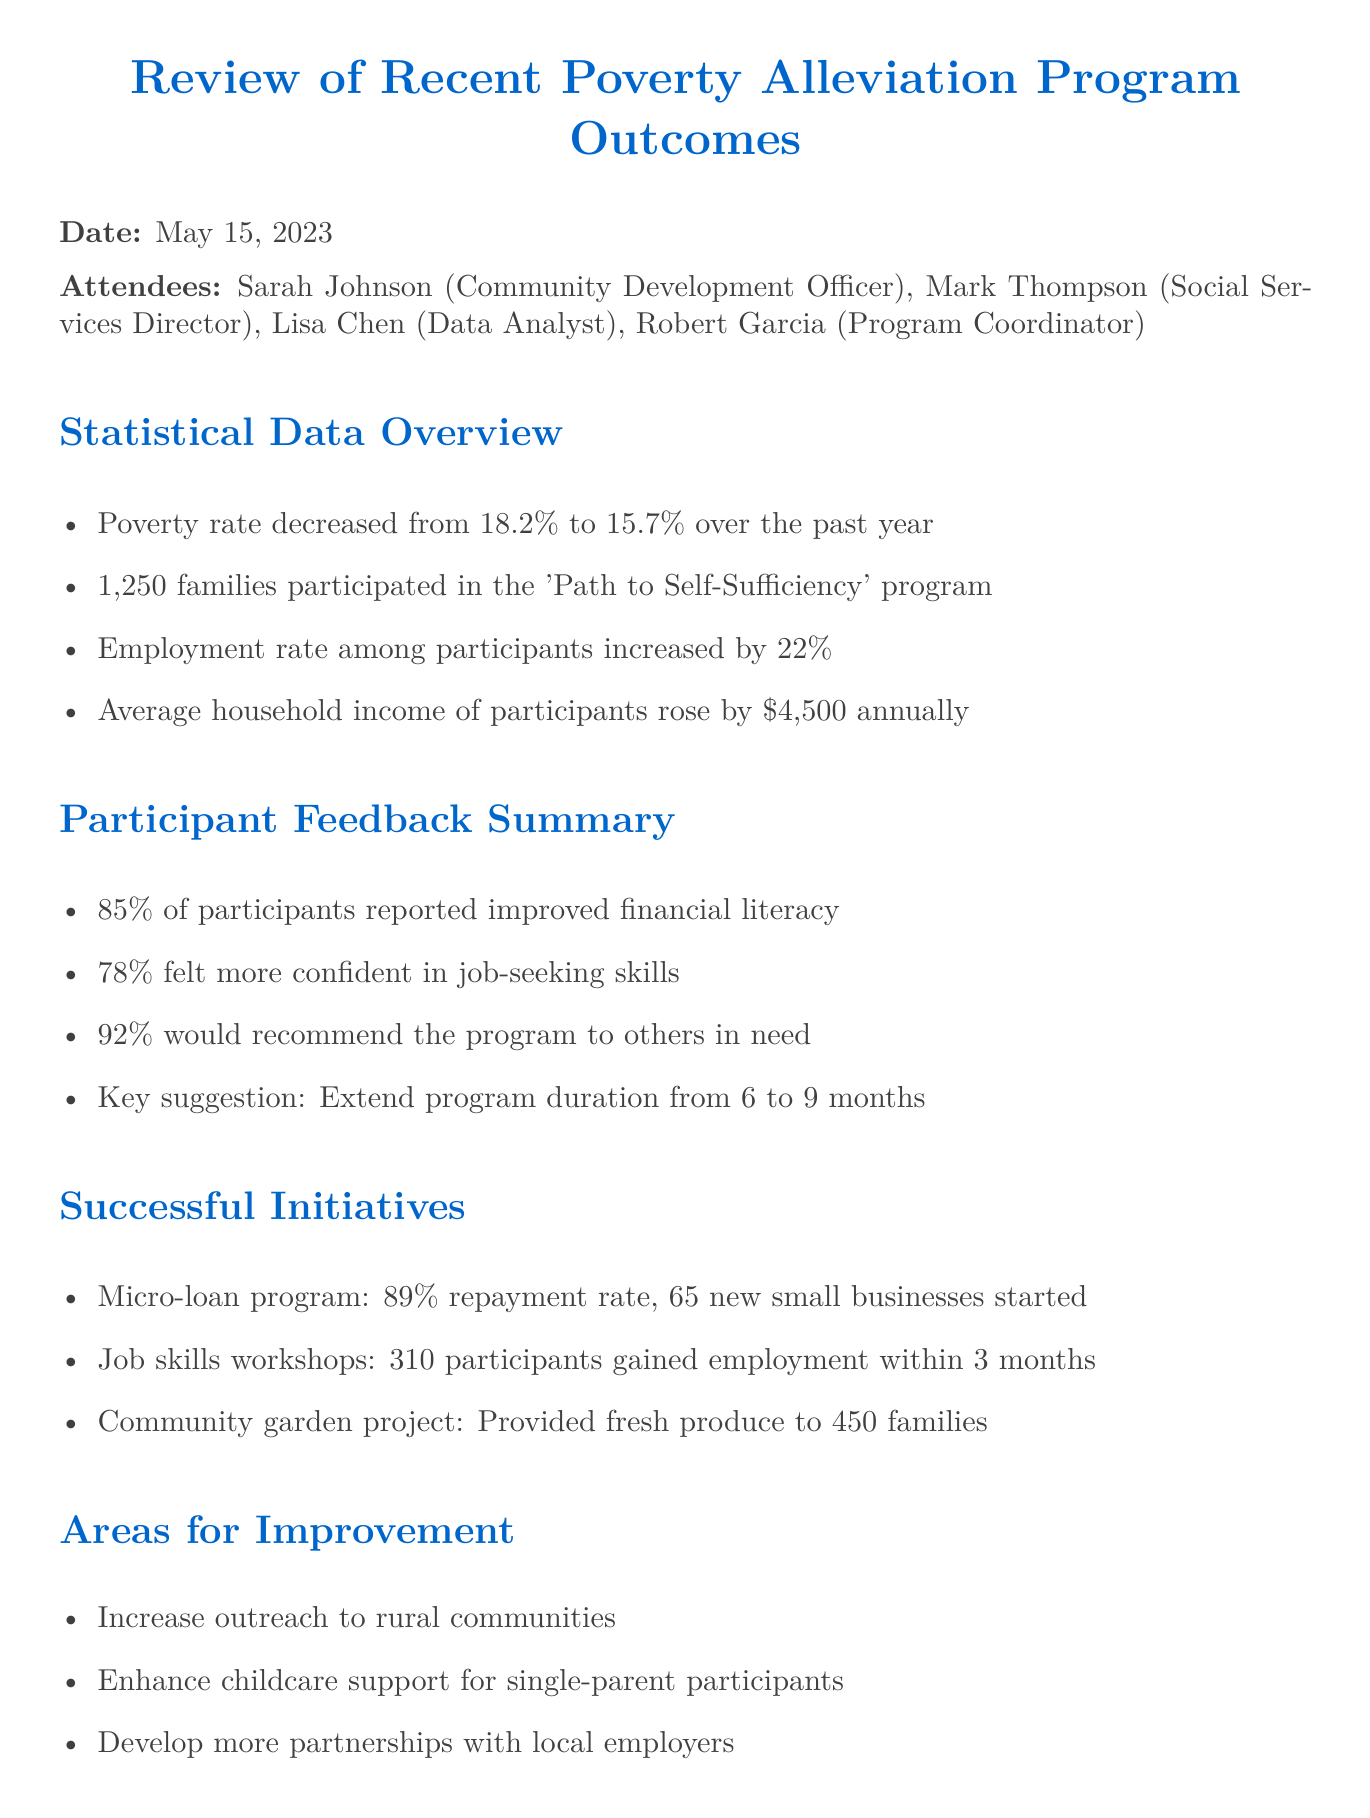What was the poverty rate decrease over the past year? The document states that the poverty rate decreased from 18.2% to 15.7%. The difference is 2.5%.
Answer: 2.5% How many families participated in the 'Path to Self-Sufficiency' program? The document explicitly mentions that 1,250 families participated in the program.
Answer: 1,250 What percentage of participants reported improved financial literacy? The meeting minutes indicate that 85% of participants reported improved financial literacy.
Answer: 85% What key suggestion was made by participants regarding the program duration? The document notes that participants suggested extending the program duration from 6 to 9 months.
Answer: Extend program duration from 6 to 9 months How many new small businesses were started through the micro-loan program? According to the document, the micro-loan program led to the establishment of 65 new small businesses.
Answer: 65 What is the average increase in household income among participants? The document reveals that the average household income of participants rose by $4,500 annually.
Answer: $4,500 What areas for improvement were suggested? The document mentions several areas for improvement, including increasing outreach to rural communities and enhancing childcare support for single-parent participants.
Answer: Increase outreach to rural communities What is one of the next steps for the program? The document lists several next steps, one being to expand the 'Path to Self-Sufficiency' program to accommodate 1,500 families.
Answer: Expand to accommodate 1,500 families What was the employment rate increase among participants? The document states that the employment rate among participants increased by 22%.
Answer: 22% 